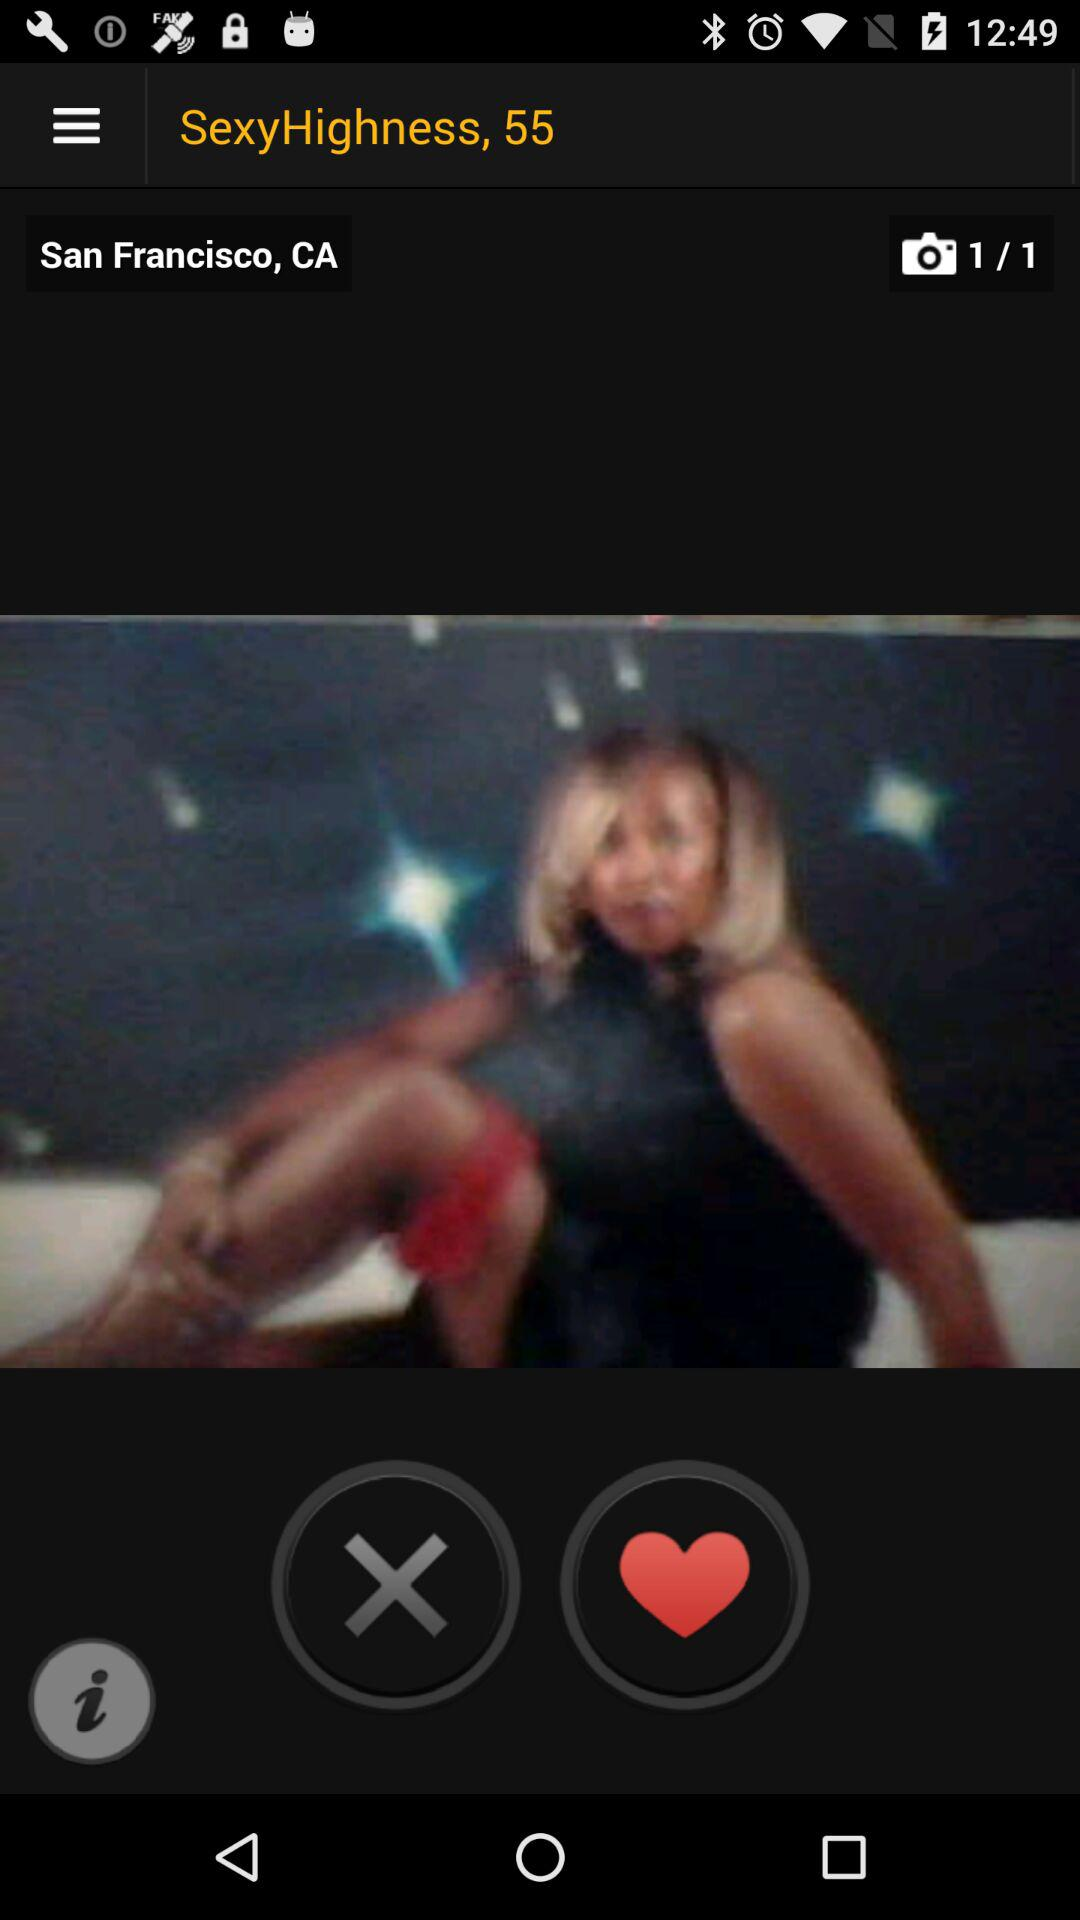What is the age of "SexyHighness"? The age is 55. 